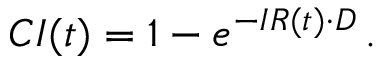<formula> <loc_0><loc_0><loc_500><loc_500>C I ( t ) = 1 - e ^ { - I R ( t ) \cdot D } \, .</formula> 